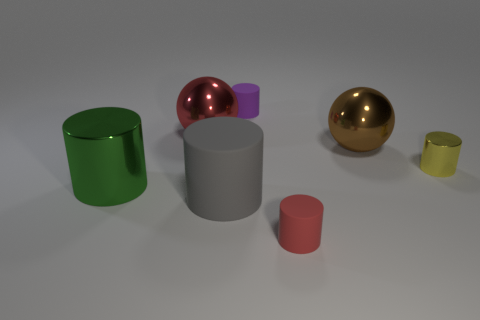Subtract all small purple rubber cylinders. How many cylinders are left? 4 Subtract all gray cylinders. How many cylinders are left? 4 Subtract all blue cylinders. Subtract all gray cubes. How many cylinders are left? 5 Add 3 small yellow cylinders. How many objects exist? 10 Subtract all cylinders. How many objects are left? 2 Add 4 gray cylinders. How many gray cylinders are left? 5 Add 7 large shiny objects. How many large shiny objects exist? 10 Subtract 0 purple blocks. How many objects are left? 7 Subtract all red balls. Subtract all big metal cylinders. How many objects are left? 5 